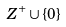<formula> <loc_0><loc_0><loc_500><loc_500>Z ^ { + } \cup \{ 0 \}</formula> 